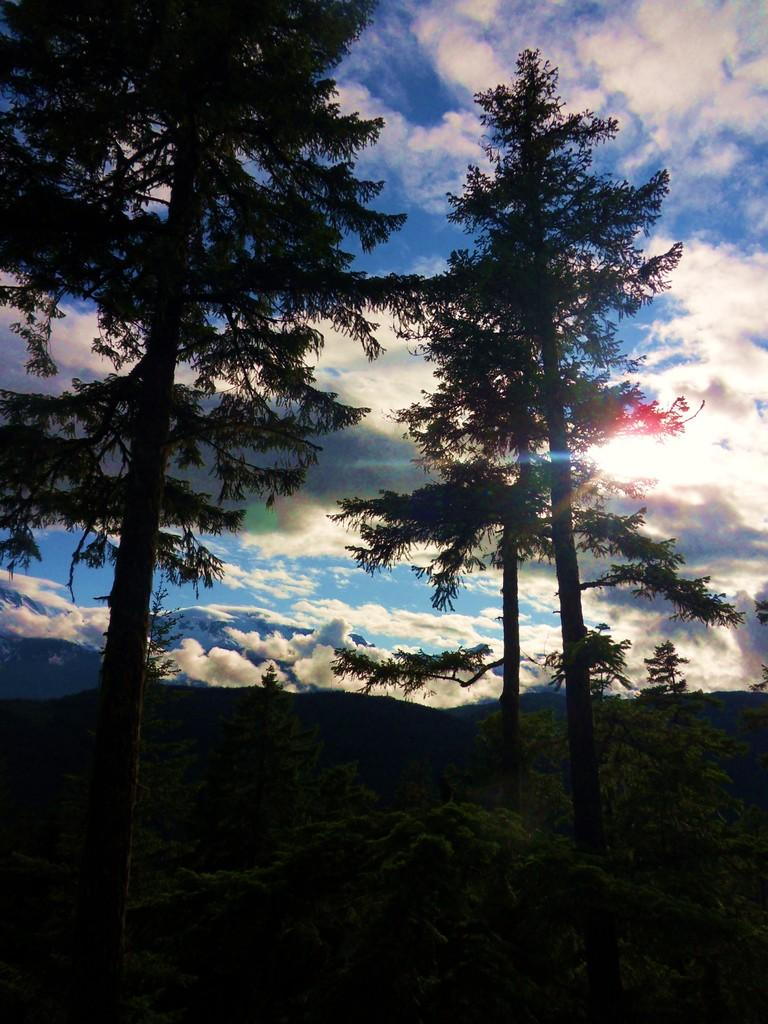What type of vegetation can be seen in the image? There are trees in the image. What is visible at the top of the image? The sky is visible at the top of the image. What can be observed in the sky? There are clouds in the sky. How would you describe the lighting in the image? The bottom part of the image appears to be dark. Can you tell me how many people are present in the image? There is no person present in the image; it features trees, sky, clouds, and a dark bottom part. What type of home is visible in the image? There is no home present in the image. 